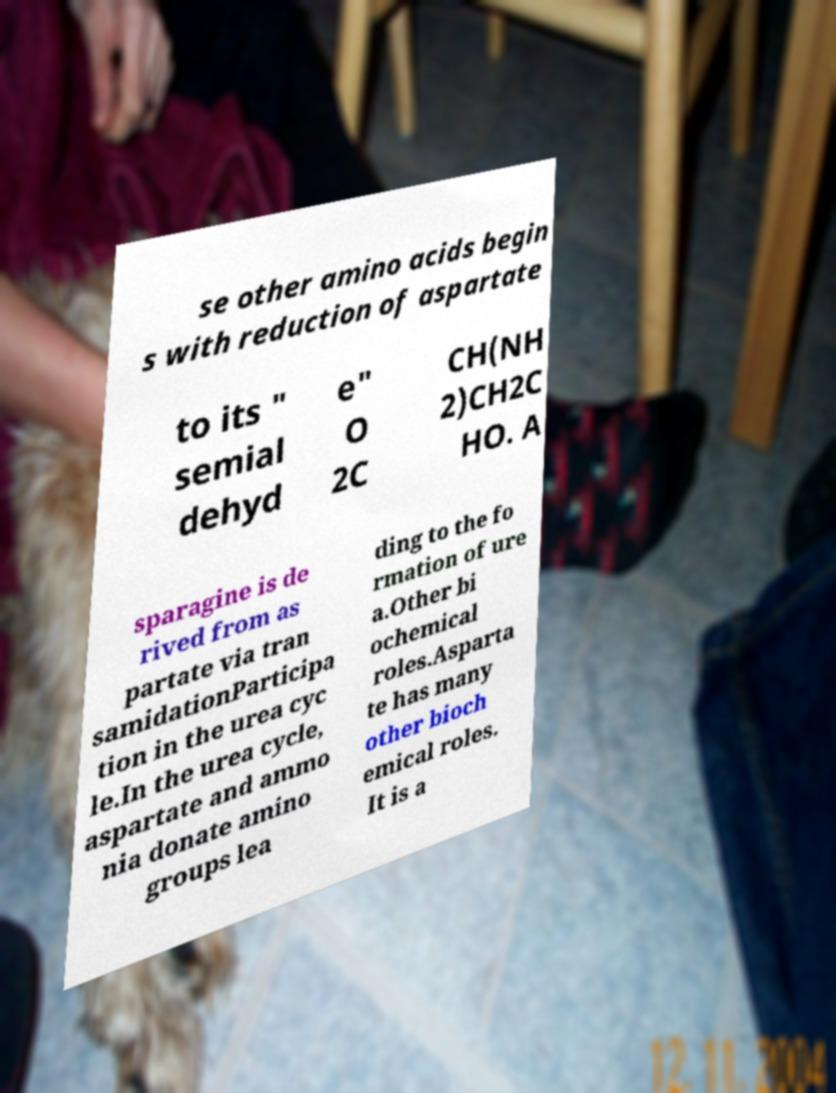For documentation purposes, I need the text within this image transcribed. Could you provide that? se other amino acids begin s with reduction of aspartate to its " semial dehyd e" O 2C CH(NH 2)CH2C HO. A sparagine is de rived from as partate via tran samidationParticipa tion in the urea cyc le.In the urea cycle, aspartate and ammo nia donate amino groups lea ding to the fo rmation of ure a.Other bi ochemical roles.Asparta te has many other bioch emical roles. It is a 